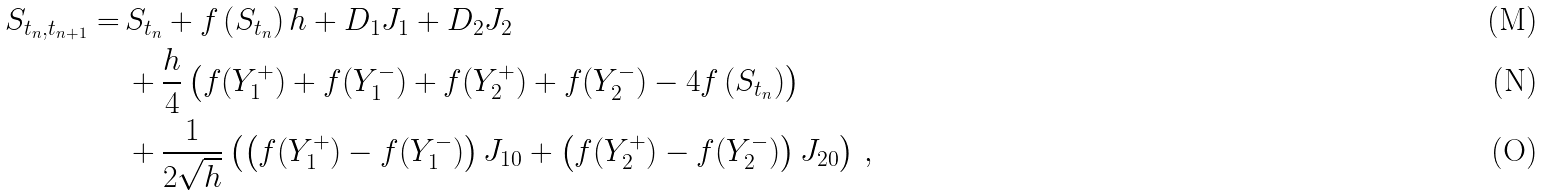Convert formula to latex. <formula><loc_0><loc_0><loc_500><loc_500>S _ { t _ { n } , t _ { n + 1 } } = & \, S _ { t _ { n } } + f \left ( S _ { t _ { n } } \right ) h + D _ { 1 } J _ { 1 } + D _ { 2 } J _ { 2 } \\ & \, + \frac { h } { 4 } \left ( f ( Y _ { 1 } ^ { + } ) + f ( Y _ { 1 } ^ { - } ) + f ( Y _ { 2 } ^ { + } ) + f ( Y _ { 2 } ^ { - } ) - 4 f \left ( S _ { t _ { n } } \right ) \right ) \\ & \, + \frac { 1 } { 2 \sqrt { h } } \left ( \left ( f ( Y _ { 1 } ^ { + } ) - f ( Y _ { 1 } ^ { - } ) \right ) J _ { 1 0 } + \left ( f ( Y _ { 2 } ^ { + } ) - f ( Y _ { 2 } ^ { - } ) \right ) J _ { 2 0 } \right ) \, ,</formula> 